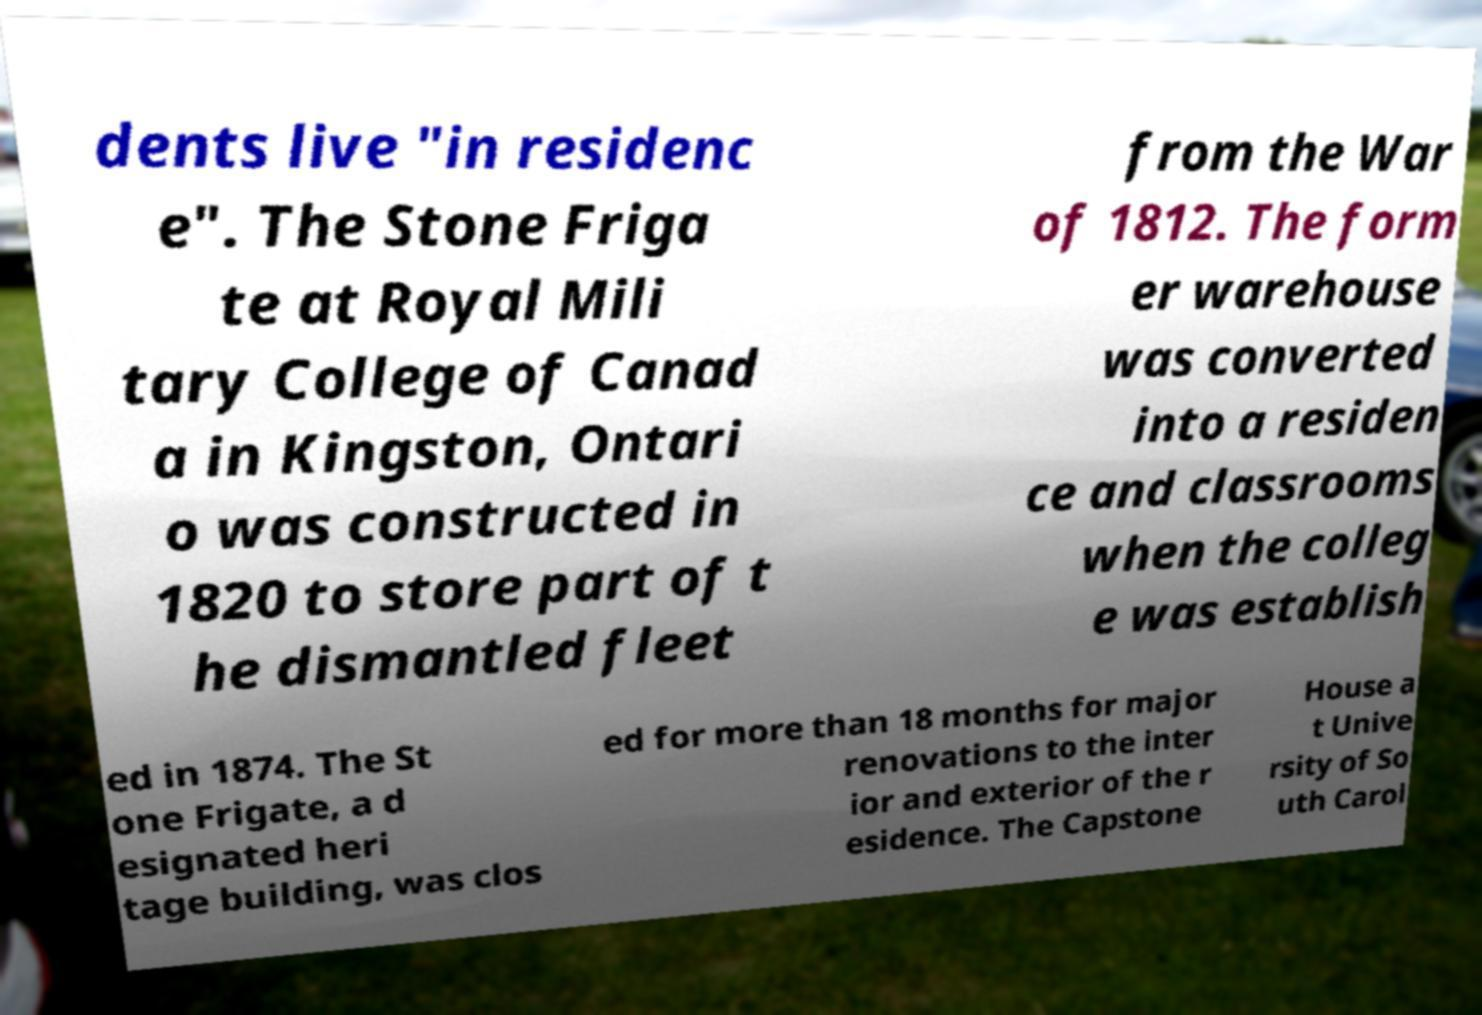I need the written content from this picture converted into text. Can you do that? dents live "in residenc e". The Stone Friga te at Royal Mili tary College of Canad a in Kingston, Ontari o was constructed in 1820 to store part of t he dismantled fleet from the War of 1812. The form er warehouse was converted into a residen ce and classrooms when the colleg e was establish ed in 1874. The St one Frigate, a d esignated heri tage building, was clos ed for more than 18 months for major renovations to the inter ior and exterior of the r esidence. The Capstone House a t Unive rsity of So uth Carol 